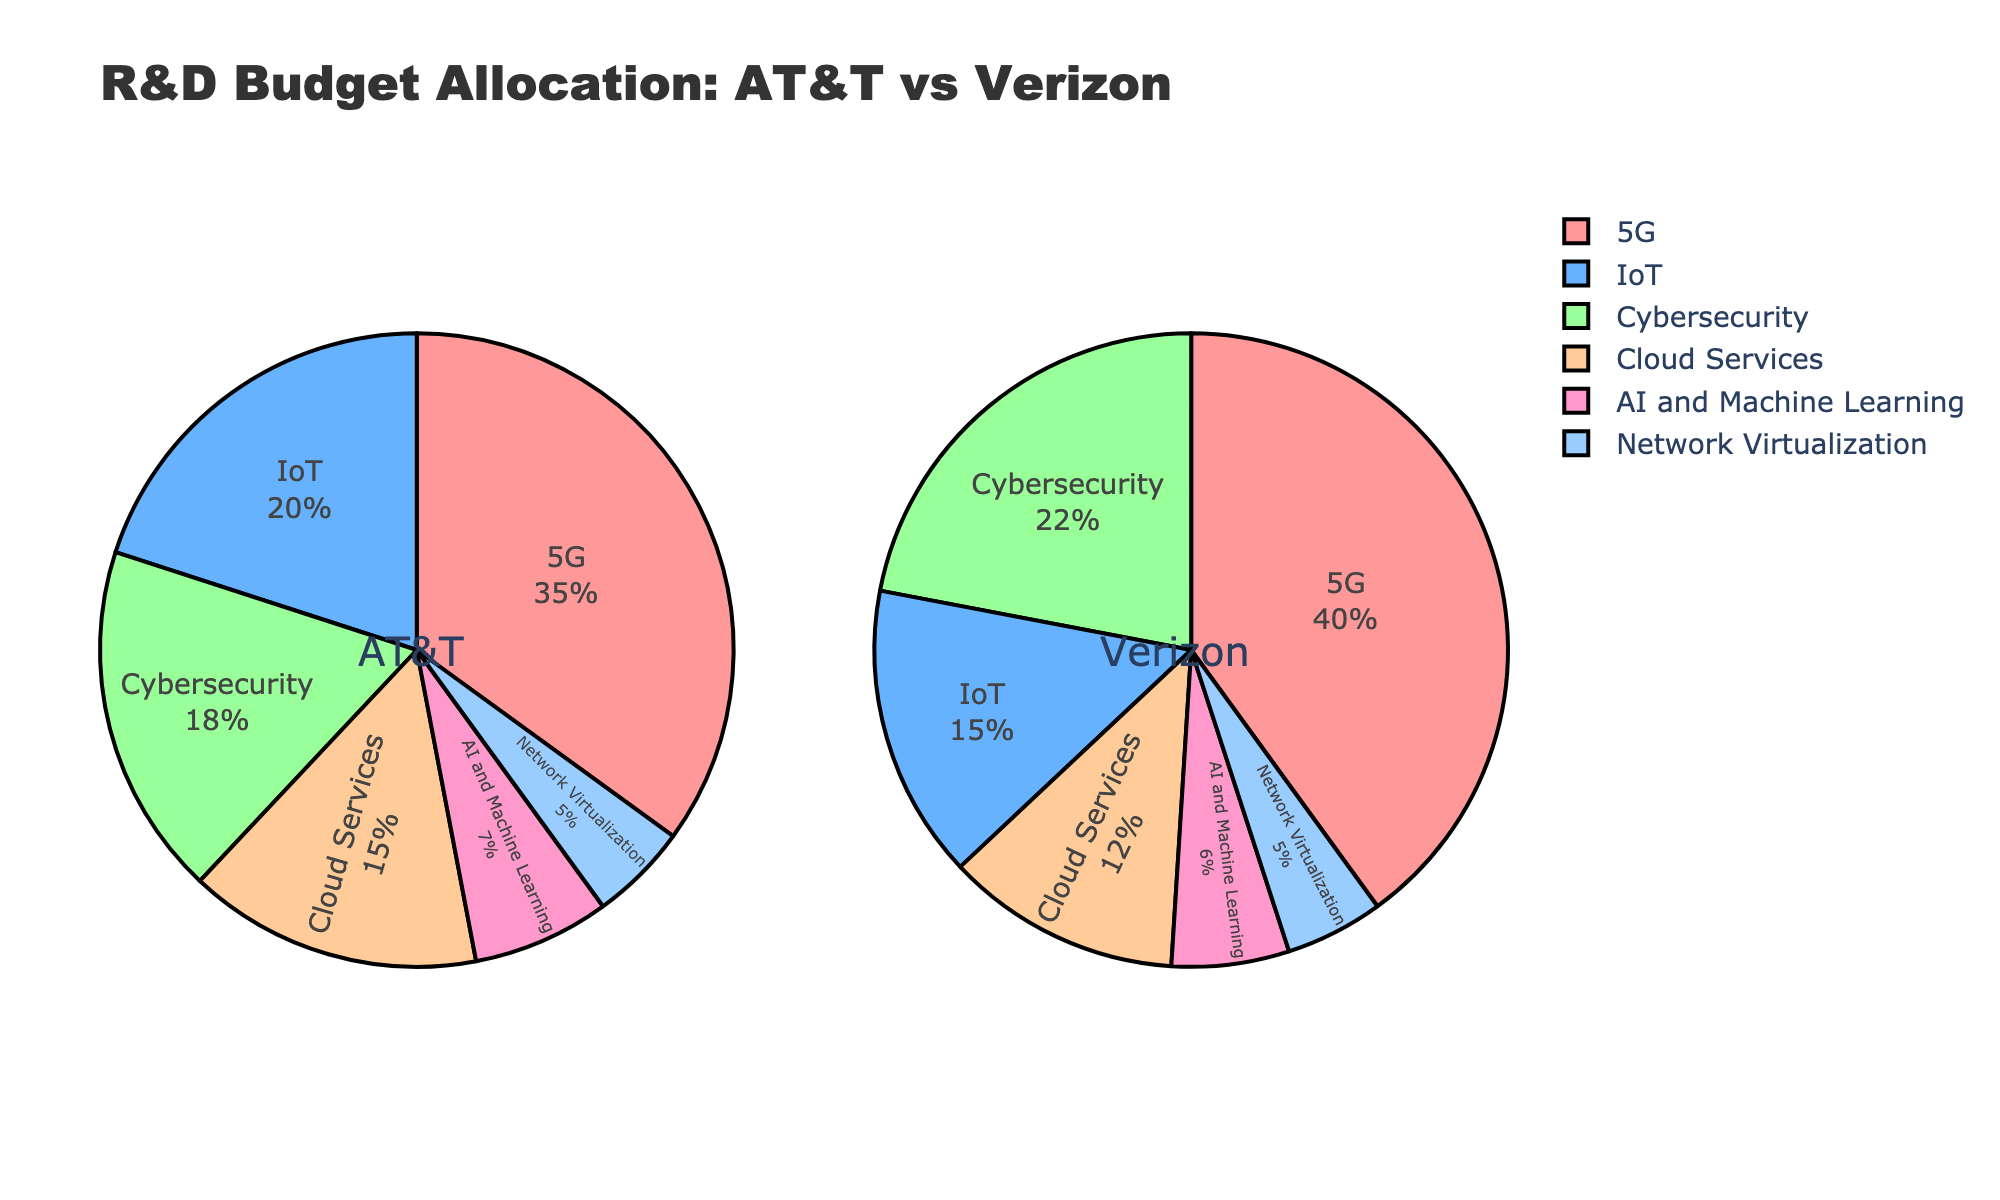What percentage of AT&T's R&D budget is allocated to 5G? The pie chart for AT&T shows that 35% of its R&D budget is allocated to 5G.
Answer: 35% Which company allocates a greater percentage of their R&D budget to cybersecurity? The pie charts indicate that Verizon allocates 22% of its R&D budget to cybersecurity, whereas AT&T allocates 18%. Therefore, Verizon allocates a greater percentage.
Answer: Verizon How much more does Verizon allocate to 5G compared to AT&T? Verizon allocates 40% of its R&D budget to 5G, while AT&T allocates 35%. The difference is 40% - 35% = 5%.
Answer: 5% What is the combined percentage of AT&T's budget allocated to IoT and AI and Machine Learning? AT&T allocates 20% to IoT and 7% to AI and Machine Learning. The combined percentage is 20% + 7% = 27%.
Answer: 27% Which technology focus has the same budget allocation for both AT&T and Verizon? According to the pie charts, Network Virtualization has the same budget allocation for both AT&T and Verizon, at 5%.
Answer: Network Virtualization Is there a technology focus where AT&T allocates a higher percentage than Verizon does? Yes, AT&T allocates a higher percentage than Verizon to IoT (20% vs. 15%) and Cloud Services (15% vs. 12%).
Answer: Yes What is the total percentage pie allocation for AT&T and Verizon? For AT&T: 35 + 20 + 18 + 15 + 7 + 5 = 100%. For Verizon: 40 + 15 + 22 + 12 + 6 + 5 = 100%. Both companies allocate 100% of their budget across the technologies.
Answer: 100% How much more does Verizon allocate to Cloud Services compared to AI and Machine Learning? Verizon allocates 12% to Cloud Services and 6% to AI and Machine Learning. The difference is 12% - 6% = 6%.
Answer: 6% What is the difference in percentage allocation to IoT between AT&T and Verizon? AT&T allocates 20% to IoT, while Verizon allocates 15%. The difference is 20% - 15% = 5%.
Answer: 5% Which technology focus has the least allocation from AT&T and what percentage is it? The pie chart for AT&T shows that Network Virtualization has the least allocation, at 5%.
Answer: Network Virtualization, 5% 